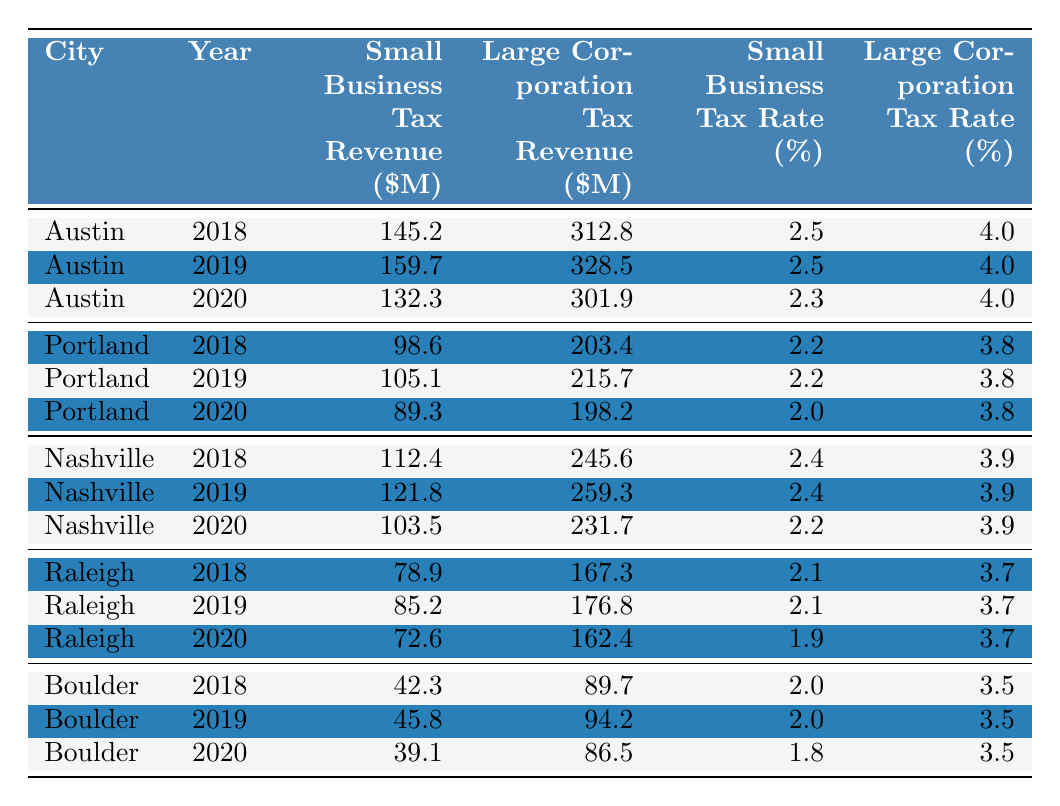What city had the highest small business tax revenue in 2019? Looking at the table, the small business tax revenue for Austin in 2019 is 159.7 million, which is higher than any other city's revenue for the same year.
Answer: Austin In which year did Raleigh have the lowest small business tax revenue? By examining the table, Raleigh's small business tax revenues for each year are 78.9 million (2018), 85.2 million (2019), and 72.6 million (2020). The lowest is in 2020 at 72.6 million.
Answer: 2020 What is the total small business tax revenue for Nashville from 2018 to 2020? To find this sum, add the small business tax revenues for Nashville across the years: 112.4 + 121.8 + 103.5 = 337.7 million.
Answer: 337.7 million Did Austin ever generate more small business tax revenue than large corporation tax revenue during the years shown? Checking the data: Austin's small business tax revenue is 145.2 million (2018), 159.7 million (2019), and 132.3 million (2020); compared to large corporations, which are 312.8 million, 328.5 million, and 301.9 million respectively. In every year, small business revenue is less than large corporations.
Answer: No What was the average small business tax revenue across all cities in 2020? The small business tax revenue for 2020 is: Austin 132.3, Portland 89.3, Nashville 103.5, Raleigh 72.6, and Boulder 39.1. Summing these gives 132.3 + 89.3 + 103.5 + 72.6 + 39.1 = 436.8 million. There are 5 cities, so the average is 436.8/5 = 87.36 million.
Answer: 87.36 million Which city had the highest large corporation tax revenue in 2018? In 2018, the large corporation tax revenues are: Austin 312.8 million, Portland 203.4 million, Nashville 245.6 million, Raleigh 167.3 million, and Boulder 89.7 million. Austin has the highest amount at 312.8 million.
Answer: Austin What is the difference between large corporation and small business tax revenue for Portland in 2019? For Portland in 2019, small business tax revenue is 105.1 million and large corporation tax revenue is 215.7 million. The difference is 215.7 - 105.1 = 110.6 million.
Answer: 110.6 million Was the small business tax rate in Boulder higher than in Nashville in 2019? From the table, Boulder had a small business tax rate of 2.0% while Nashville had 2.4%. Since 2.4% is higher than 2.0%, the statement is false.
Answer: No What trend is observed in the small business tax revenue for Boulder from 2018 to 2020? The values for Boulder are 42.3 million (2018), 45.8 million (2019), and 39.1 million (2020). The revenue increased from 2018 to 2019, but then decreased in 2020. This indicates a decline after the increase.
Answer: Declining after an increase 